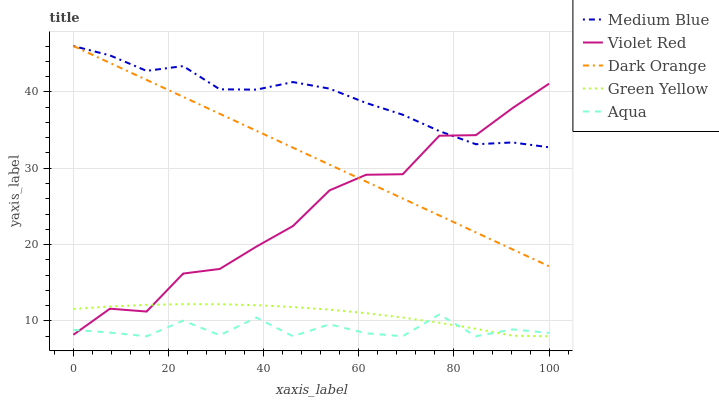Does Aqua have the minimum area under the curve?
Answer yes or no. Yes. Does Medium Blue have the maximum area under the curve?
Answer yes or no. Yes. Does Dark Orange have the minimum area under the curve?
Answer yes or no. No. Does Dark Orange have the maximum area under the curve?
Answer yes or no. No. Is Dark Orange the smoothest?
Answer yes or no. Yes. Is Aqua the roughest?
Answer yes or no. Yes. Is Violet Red the smoothest?
Answer yes or no. No. Is Violet Red the roughest?
Answer yes or no. No. Does Aqua have the lowest value?
Answer yes or no. Yes. Does Dark Orange have the lowest value?
Answer yes or no. No. Does Medium Blue have the highest value?
Answer yes or no. Yes. Does Violet Red have the highest value?
Answer yes or no. No. Is Green Yellow less than Dark Orange?
Answer yes or no. Yes. Is Dark Orange greater than Aqua?
Answer yes or no. Yes. Does Green Yellow intersect Violet Red?
Answer yes or no. Yes. Is Green Yellow less than Violet Red?
Answer yes or no. No. Is Green Yellow greater than Violet Red?
Answer yes or no. No. Does Green Yellow intersect Dark Orange?
Answer yes or no. No. 